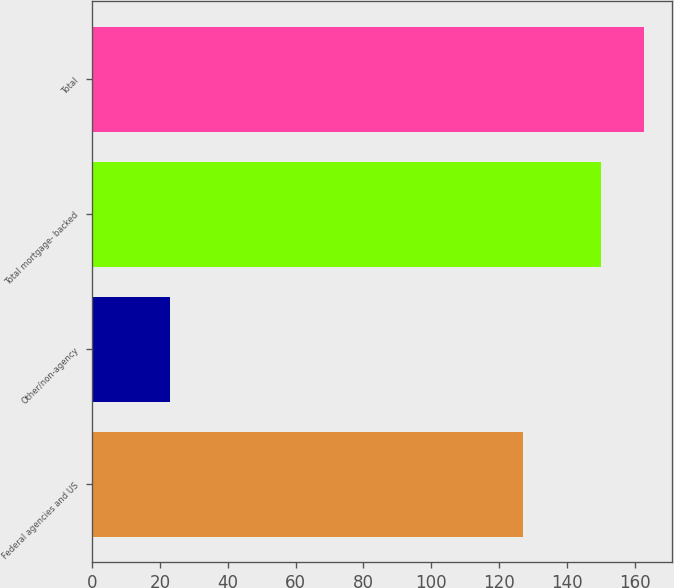Convert chart to OTSL. <chart><loc_0><loc_0><loc_500><loc_500><bar_chart><fcel>Federal agencies and US<fcel>Other/non-agency<fcel>Total mortgage- backed<fcel>Total<nl><fcel>127<fcel>23<fcel>150<fcel>162.8<nl></chart> 